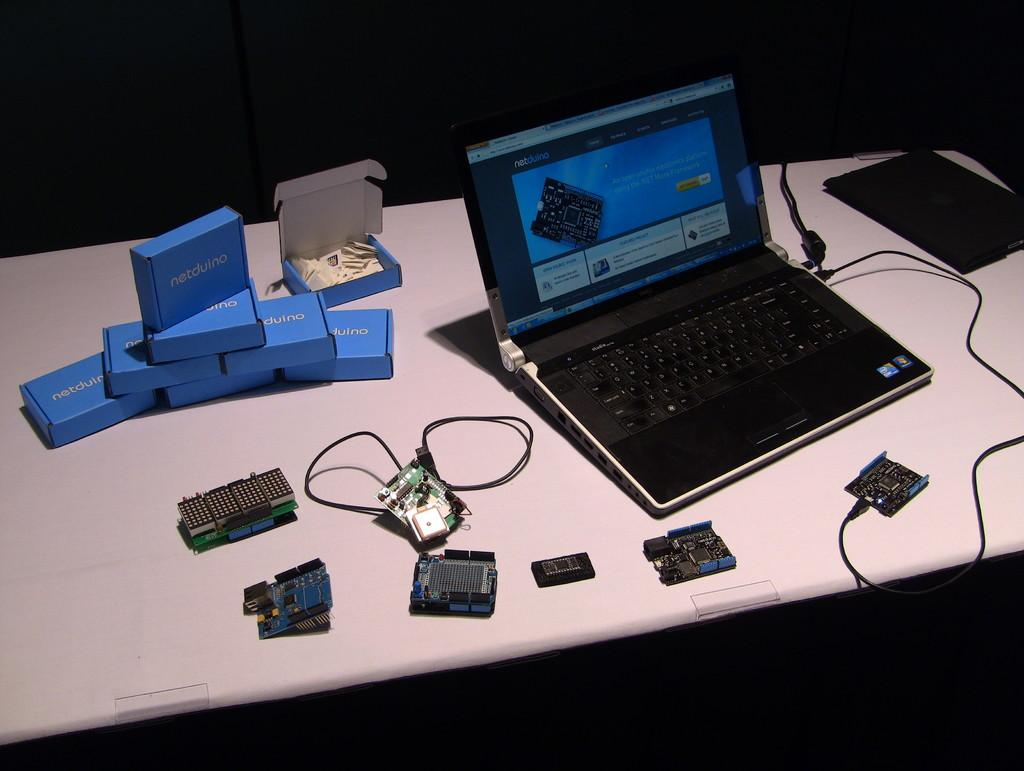<image>
Write a terse but informative summary of the picture. An open laptop is on a table next to a pile of small blue boxes labeled netduino. 